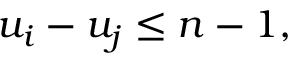<formula> <loc_0><loc_0><loc_500><loc_500>u _ { i } - u _ { j } \leq n - 1 ,</formula> 